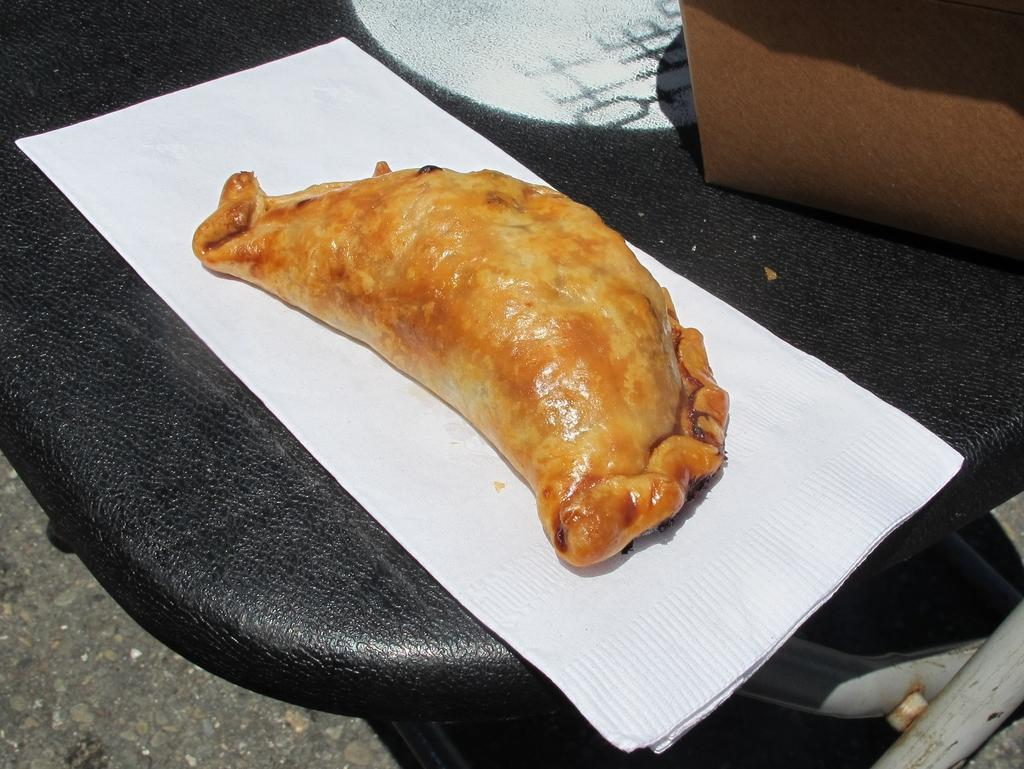What piece of furniture is present in the image? There is a table in the image. What can be found on the table? There are tissues, a food item, and a box on the table. What is visible at the bottom of the image? The floor is visible at the bottom of the image. How would you describe the weather in the image? The image is sunny. What type of bubble is floating near the food item in the image? There is no bubble present in the image. What position is the rock in on the table in the image? There is no rock present in the image. 